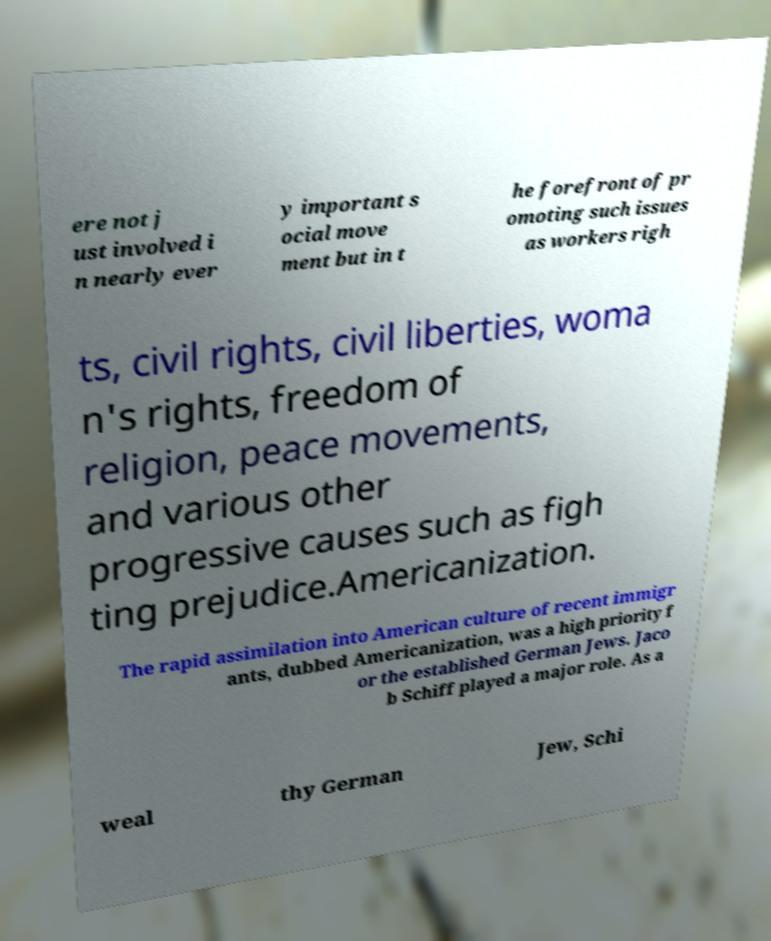For documentation purposes, I need the text within this image transcribed. Could you provide that? ere not j ust involved i n nearly ever y important s ocial move ment but in t he forefront of pr omoting such issues as workers righ ts, civil rights, civil liberties, woma n's rights, freedom of religion, peace movements, and various other progressive causes such as figh ting prejudice.Americanization. The rapid assimilation into American culture of recent immigr ants, dubbed Americanization, was a high priority f or the established German Jews. Jaco b Schiff played a major role. As a weal thy German Jew, Schi 